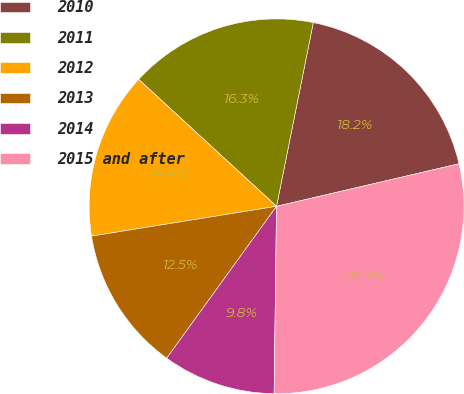Convert chart. <chart><loc_0><loc_0><loc_500><loc_500><pie_chart><fcel>2010<fcel>2011<fcel>2012<fcel>2013<fcel>2014<fcel>2015 and after<nl><fcel>18.21%<fcel>16.3%<fcel>14.39%<fcel>12.49%<fcel>9.76%<fcel>28.85%<nl></chart> 